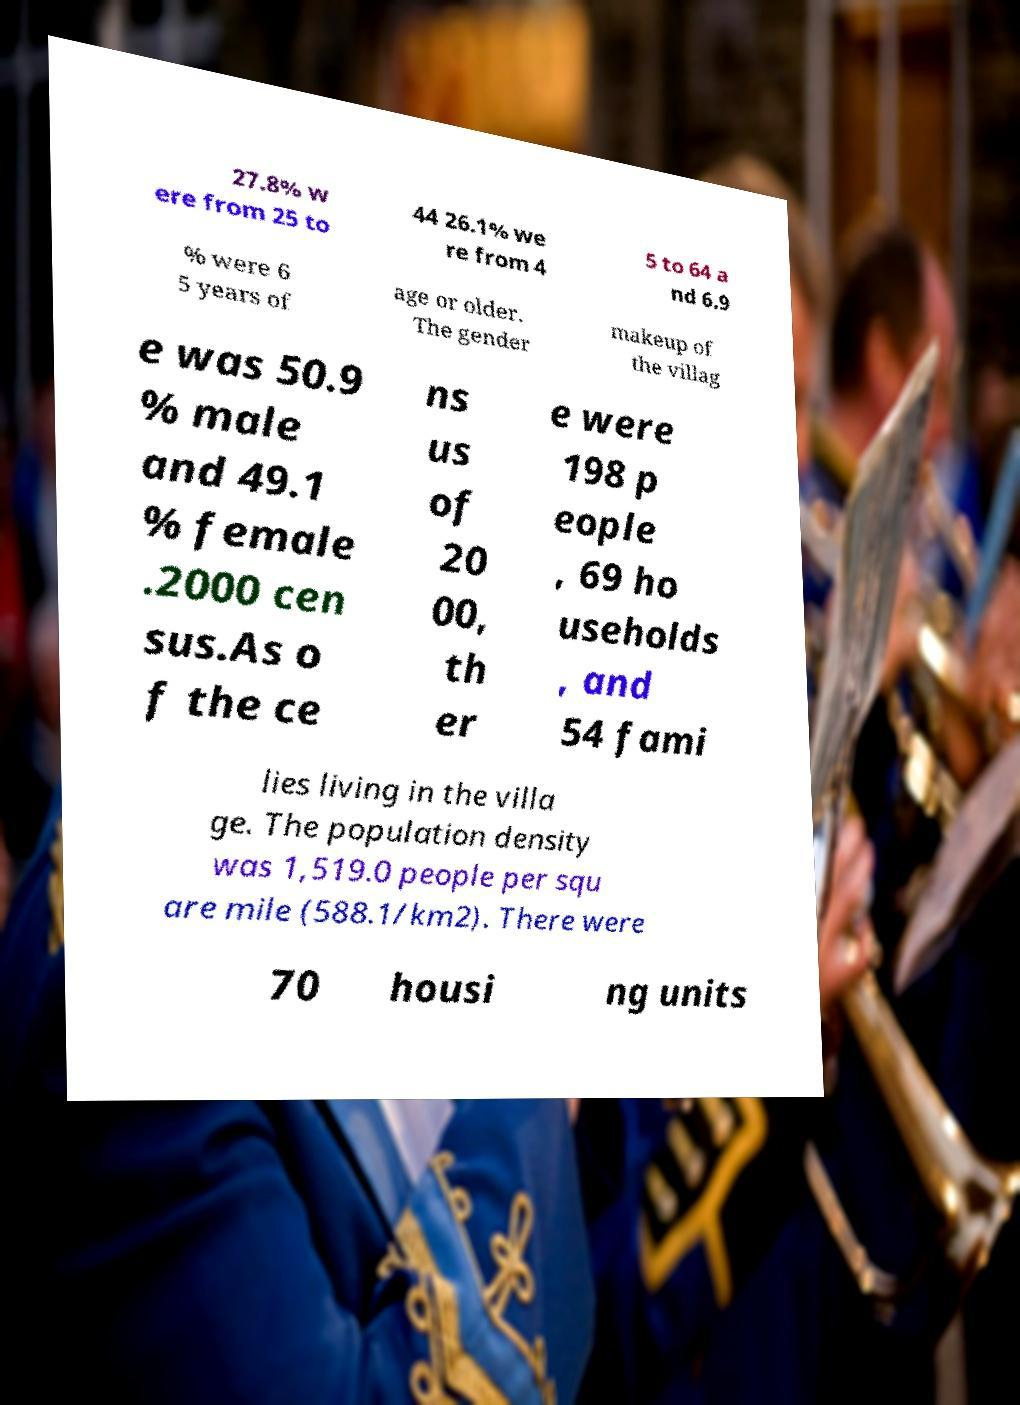Please read and relay the text visible in this image. What does it say? 27.8% w ere from 25 to 44 26.1% we re from 4 5 to 64 a nd 6.9 % were 6 5 years of age or older. The gender makeup of the villag e was 50.9 % male and 49.1 % female .2000 cen sus.As o f the ce ns us of 20 00, th er e were 198 p eople , 69 ho useholds , and 54 fami lies living in the villa ge. The population density was 1,519.0 people per squ are mile (588.1/km2). There were 70 housi ng units 